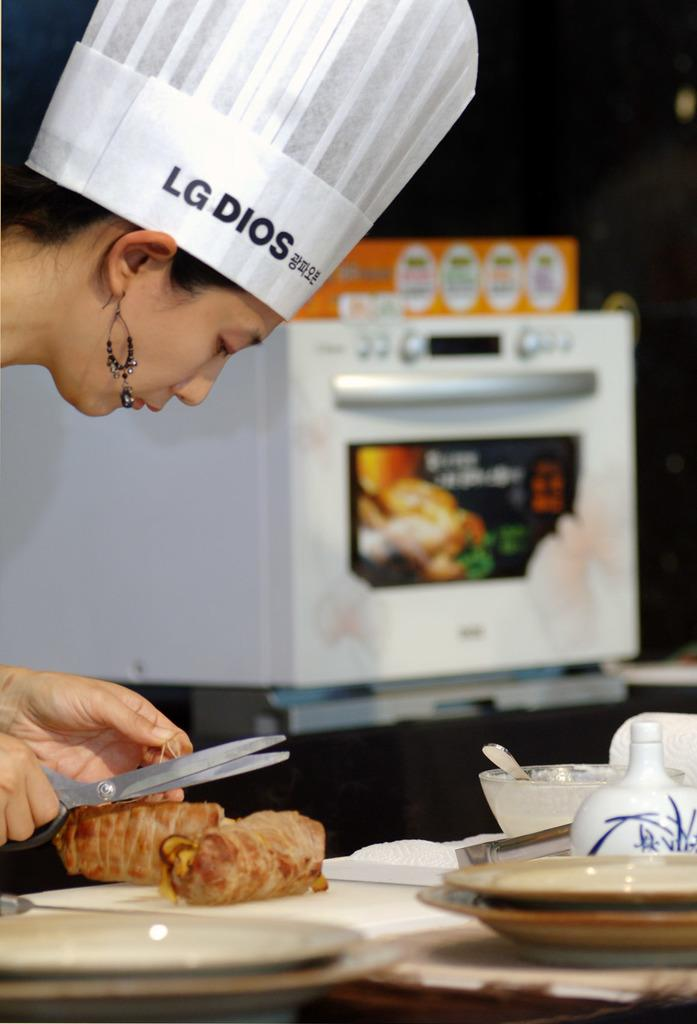<image>
Render a clear and concise summary of the photo. Chef preparing a meal while wearing a chefs hat with LG DIOS and additional chinese writing on it. 